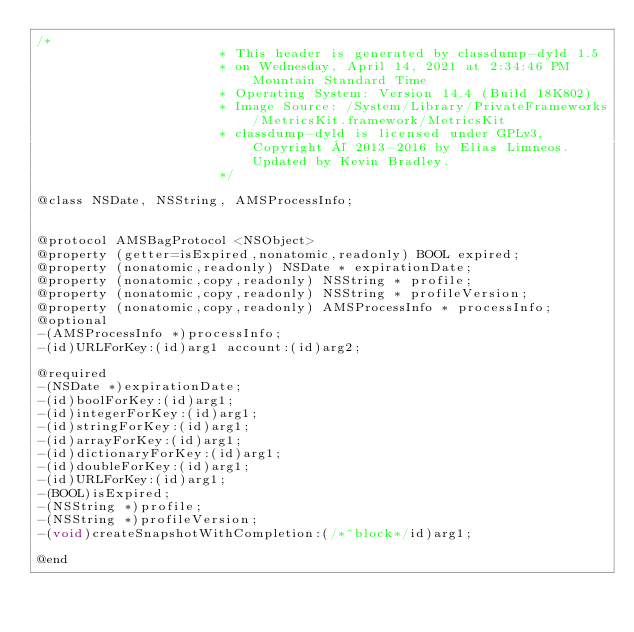Convert code to text. <code><loc_0><loc_0><loc_500><loc_500><_C_>/*
                       * This header is generated by classdump-dyld 1.5
                       * on Wednesday, April 14, 2021 at 2:34:46 PM Mountain Standard Time
                       * Operating System: Version 14.4 (Build 18K802)
                       * Image Source: /System/Library/PrivateFrameworks/MetricsKit.framework/MetricsKit
                       * classdump-dyld is licensed under GPLv3, Copyright © 2013-2016 by Elias Limneos. Updated by Kevin Bradley.
                       */

@class NSDate, NSString, AMSProcessInfo;


@protocol AMSBagProtocol <NSObject>
@property (getter=isExpired,nonatomic,readonly) BOOL expired; 
@property (nonatomic,readonly) NSDate * expirationDate; 
@property (nonatomic,copy,readonly) NSString * profile; 
@property (nonatomic,copy,readonly) NSString * profileVersion; 
@property (nonatomic,copy,readonly) AMSProcessInfo * processInfo; 
@optional
-(AMSProcessInfo *)processInfo;
-(id)URLForKey:(id)arg1 account:(id)arg2;

@required
-(NSDate *)expirationDate;
-(id)boolForKey:(id)arg1;
-(id)integerForKey:(id)arg1;
-(id)stringForKey:(id)arg1;
-(id)arrayForKey:(id)arg1;
-(id)dictionaryForKey:(id)arg1;
-(id)doubleForKey:(id)arg1;
-(id)URLForKey:(id)arg1;
-(BOOL)isExpired;
-(NSString *)profile;
-(NSString *)profileVersion;
-(void)createSnapshotWithCompletion:(/*^block*/id)arg1;

@end

</code> 